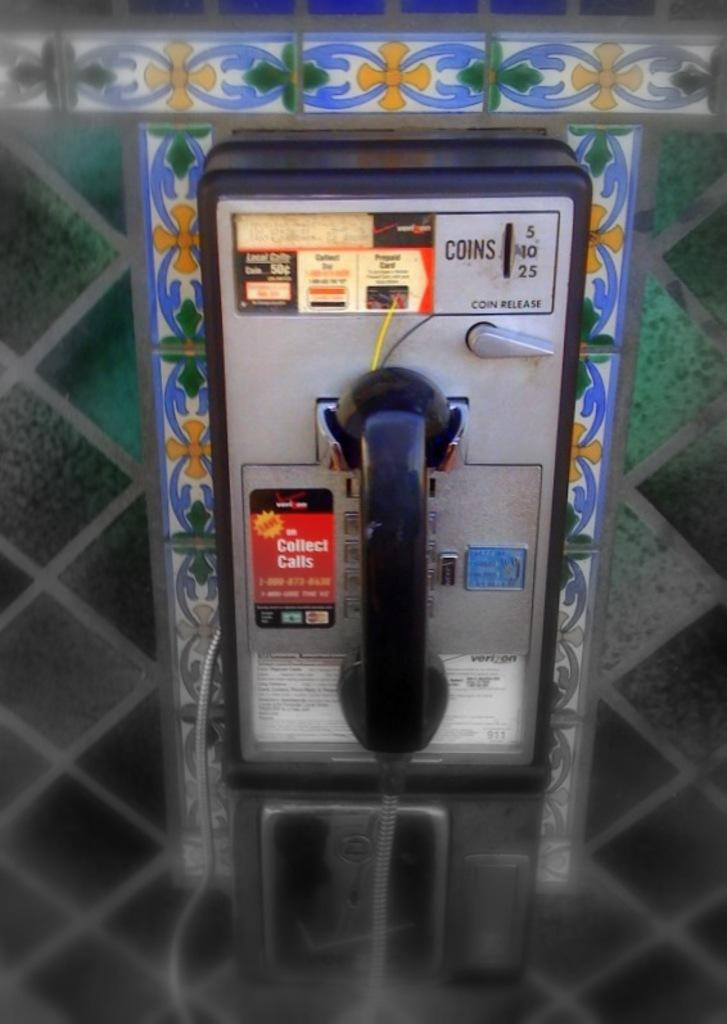<image>
Render a clear and concise summary of the photo. A pay phone has a sticker in red that says collect calls on it. 